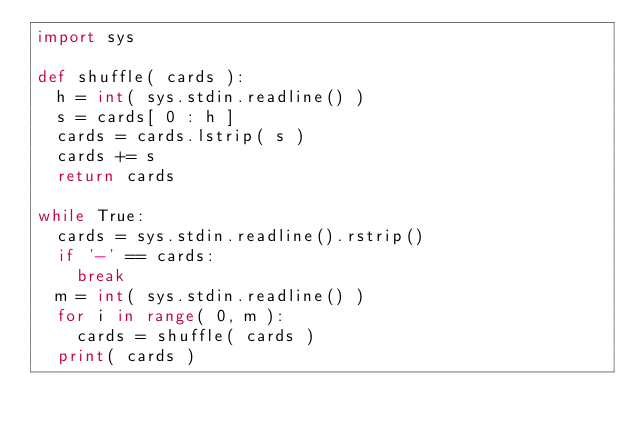<code> <loc_0><loc_0><loc_500><loc_500><_Python_>import sys

def shuffle( cards ):
	h = int( sys.stdin.readline() )
	s = cards[ 0 : h ]
	cards = cards.lstrip( s )
	cards += s
	return cards

while True:
	cards = sys.stdin.readline().rstrip()
	if '-' == cards:
		break
	m = int( sys.stdin.readline() )
	for i in range( 0, m ):
		cards = shuffle( cards )
	print( cards )</code> 